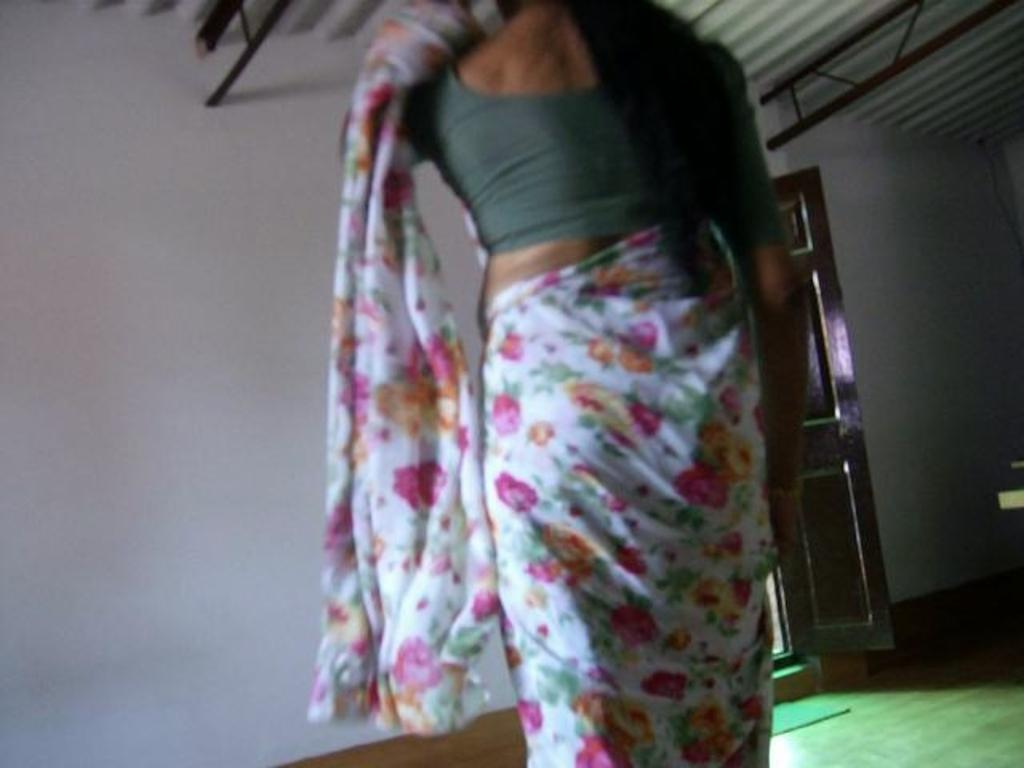Who is present in the image? There is a woman in the image. What can be seen in the background of the image? There is a wall, a door, and a mat on the floor in the background of the image. What architectural features are visible at the top of the image? There are rods visible at the top of the image. What type of structure is present in the image? There is a roof in the image. What type of seed is being planted in rhythm by the woman in the image? There is no seed or planting activity present in the image; it features a woman in a setting with a wall, door, mat, rods, and a roof. 